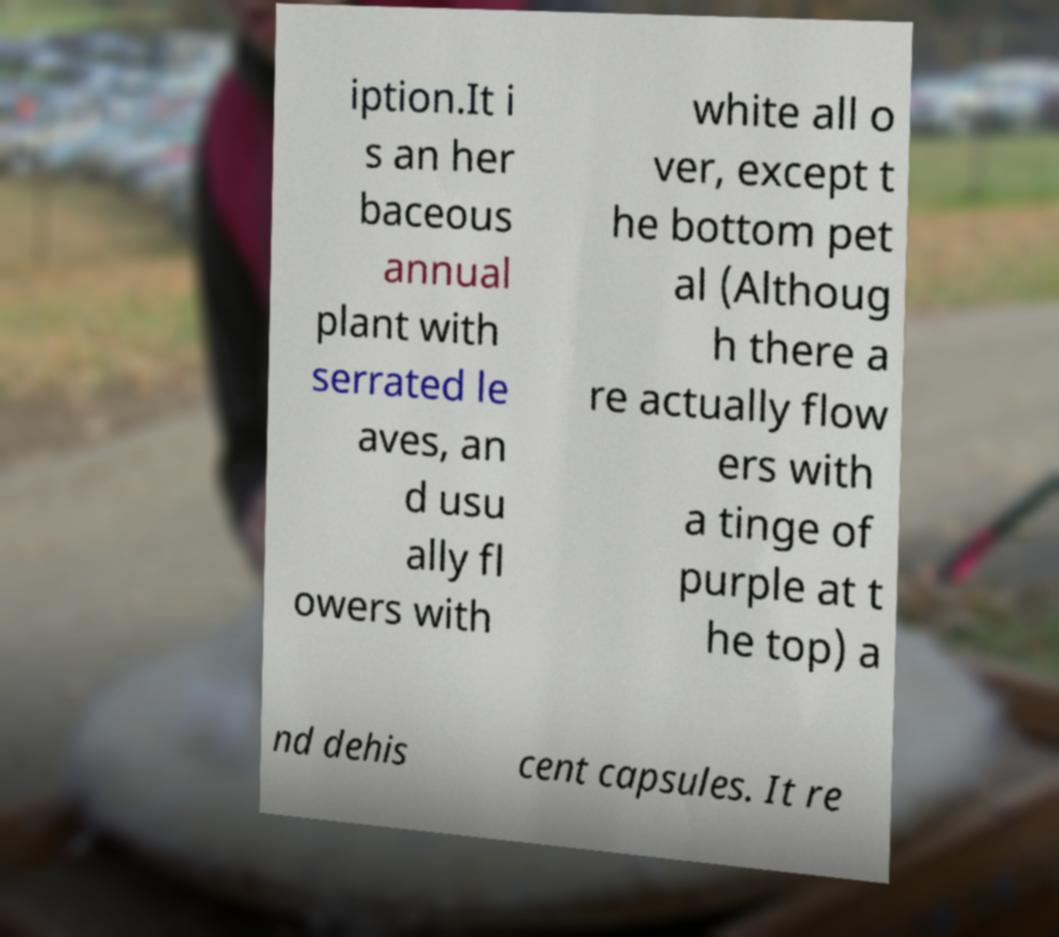Can you read and provide the text displayed in the image?This photo seems to have some interesting text. Can you extract and type it out for me? iption.It i s an her baceous annual plant with serrated le aves, an d usu ally fl owers with white all o ver, except t he bottom pet al (Althoug h there a re actually flow ers with a tinge of purple at t he top) a nd dehis cent capsules. It re 